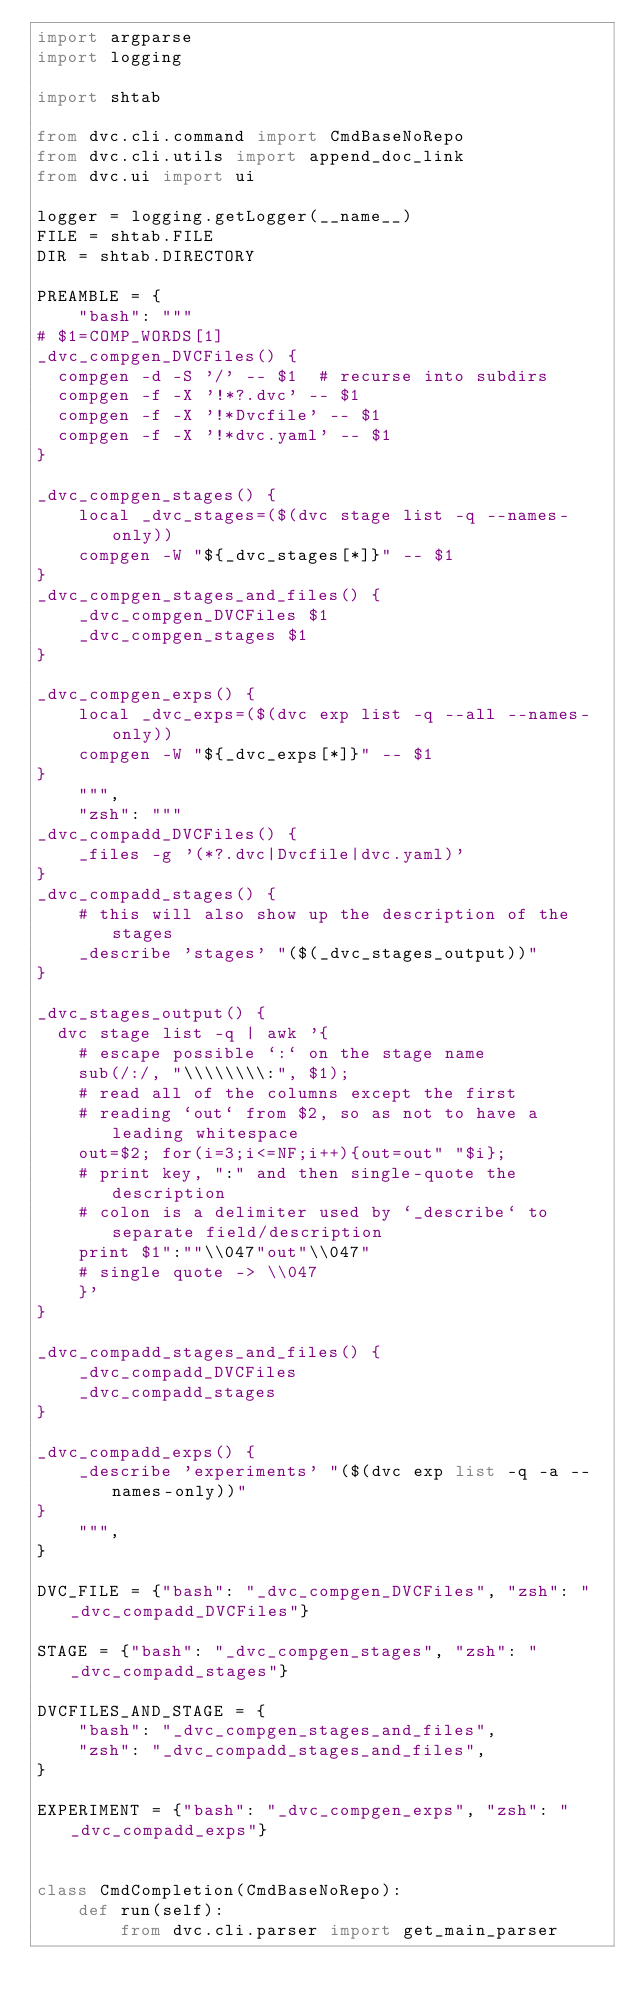Convert code to text. <code><loc_0><loc_0><loc_500><loc_500><_Python_>import argparse
import logging

import shtab

from dvc.cli.command import CmdBaseNoRepo
from dvc.cli.utils import append_doc_link
from dvc.ui import ui

logger = logging.getLogger(__name__)
FILE = shtab.FILE
DIR = shtab.DIRECTORY

PREAMBLE = {
    "bash": """
# $1=COMP_WORDS[1]
_dvc_compgen_DVCFiles() {
  compgen -d -S '/' -- $1  # recurse into subdirs
  compgen -f -X '!*?.dvc' -- $1
  compgen -f -X '!*Dvcfile' -- $1
  compgen -f -X '!*dvc.yaml' -- $1
}

_dvc_compgen_stages() {
    local _dvc_stages=($(dvc stage list -q --names-only))
    compgen -W "${_dvc_stages[*]}" -- $1
}
_dvc_compgen_stages_and_files() {
    _dvc_compgen_DVCFiles $1
    _dvc_compgen_stages $1
}

_dvc_compgen_exps() {
    local _dvc_exps=($(dvc exp list -q --all --names-only))
    compgen -W "${_dvc_exps[*]}" -- $1
}
    """,
    "zsh": """
_dvc_compadd_DVCFiles() {
    _files -g '(*?.dvc|Dvcfile|dvc.yaml)'
}
_dvc_compadd_stages() {
    # this will also show up the description of the stages
    _describe 'stages' "($(_dvc_stages_output))"
}

_dvc_stages_output() {
  dvc stage list -q | awk '{
    # escape possible `:` on the stage name
    sub(/:/, "\\\\\\\\:", $1);
    # read all of the columns except the first
    # reading `out` from $2, so as not to have a leading whitespace
    out=$2; for(i=3;i<=NF;i++){out=out" "$i};
    # print key, ":" and then single-quote the description
    # colon is a delimiter used by `_describe` to separate field/description
    print $1":""\\047"out"\\047"
    # single quote -> \\047
    }'
}

_dvc_compadd_stages_and_files() {
    _dvc_compadd_DVCFiles
    _dvc_compadd_stages
}

_dvc_compadd_exps() {
    _describe 'experiments' "($(dvc exp list -q -a --names-only))"
}
    """,
}

DVC_FILE = {"bash": "_dvc_compgen_DVCFiles", "zsh": "_dvc_compadd_DVCFiles"}

STAGE = {"bash": "_dvc_compgen_stages", "zsh": "_dvc_compadd_stages"}

DVCFILES_AND_STAGE = {
    "bash": "_dvc_compgen_stages_and_files",
    "zsh": "_dvc_compadd_stages_and_files",
}

EXPERIMENT = {"bash": "_dvc_compgen_exps", "zsh": "_dvc_compadd_exps"}


class CmdCompletion(CmdBaseNoRepo):
    def run(self):
        from dvc.cli.parser import get_main_parser
</code> 